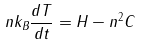<formula> <loc_0><loc_0><loc_500><loc_500>n k _ { B } \frac { d T } { d t } = H - n ^ { 2 } C</formula> 